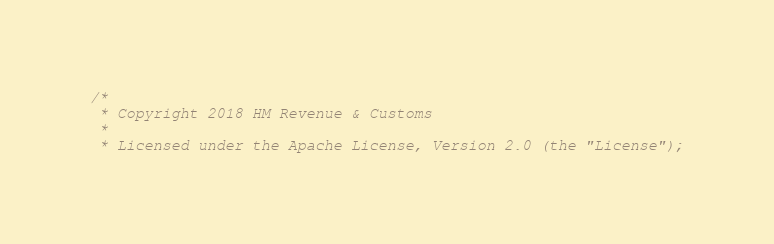Convert code to text. <code><loc_0><loc_0><loc_500><loc_500><_Scala_>/*
 * Copyright 2018 HM Revenue & Customs
 *
 * Licensed under the Apache License, Version 2.0 (the "License");</code> 